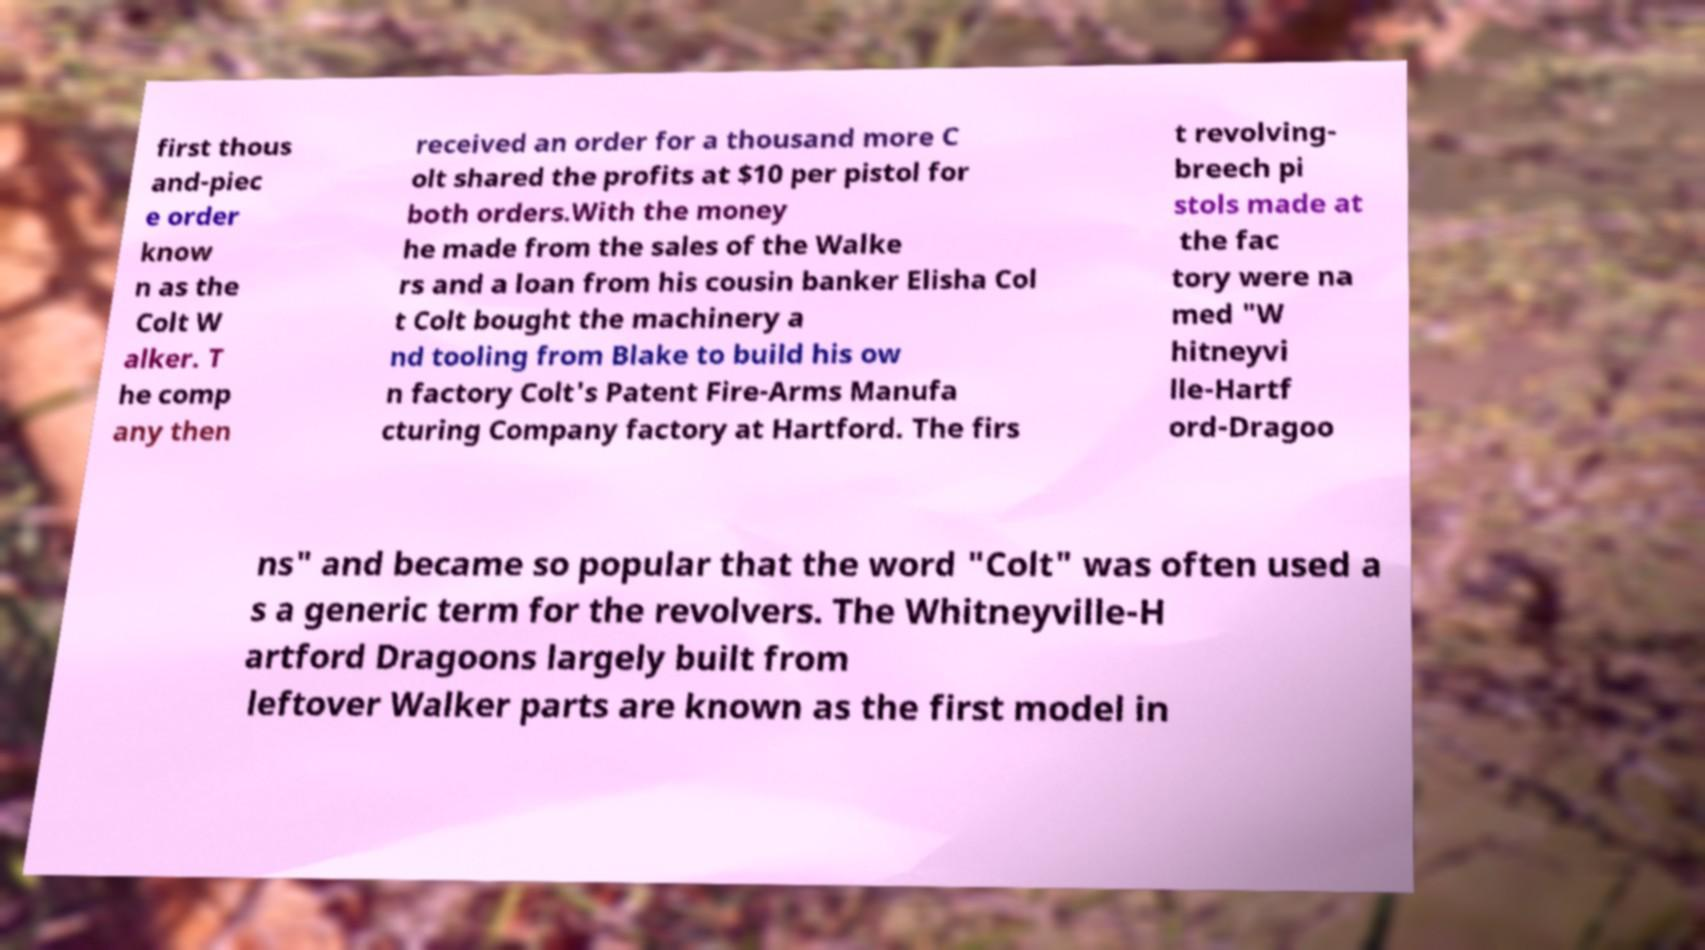I need the written content from this picture converted into text. Can you do that? first thous and-piec e order know n as the Colt W alker. T he comp any then received an order for a thousand more C olt shared the profits at $10 per pistol for both orders.With the money he made from the sales of the Walke rs and a loan from his cousin banker Elisha Col t Colt bought the machinery a nd tooling from Blake to build his ow n factory Colt's Patent Fire-Arms Manufa cturing Company factory at Hartford. The firs t revolving- breech pi stols made at the fac tory were na med "W hitneyvi lle-Hartf ord-Dragoo ns" and became so popular that the word "Colt" was often used a s a generic term for the revolvers. The Whitneyville-H artford Dragoons largely built from leftover Walker parts are known as the first model in 